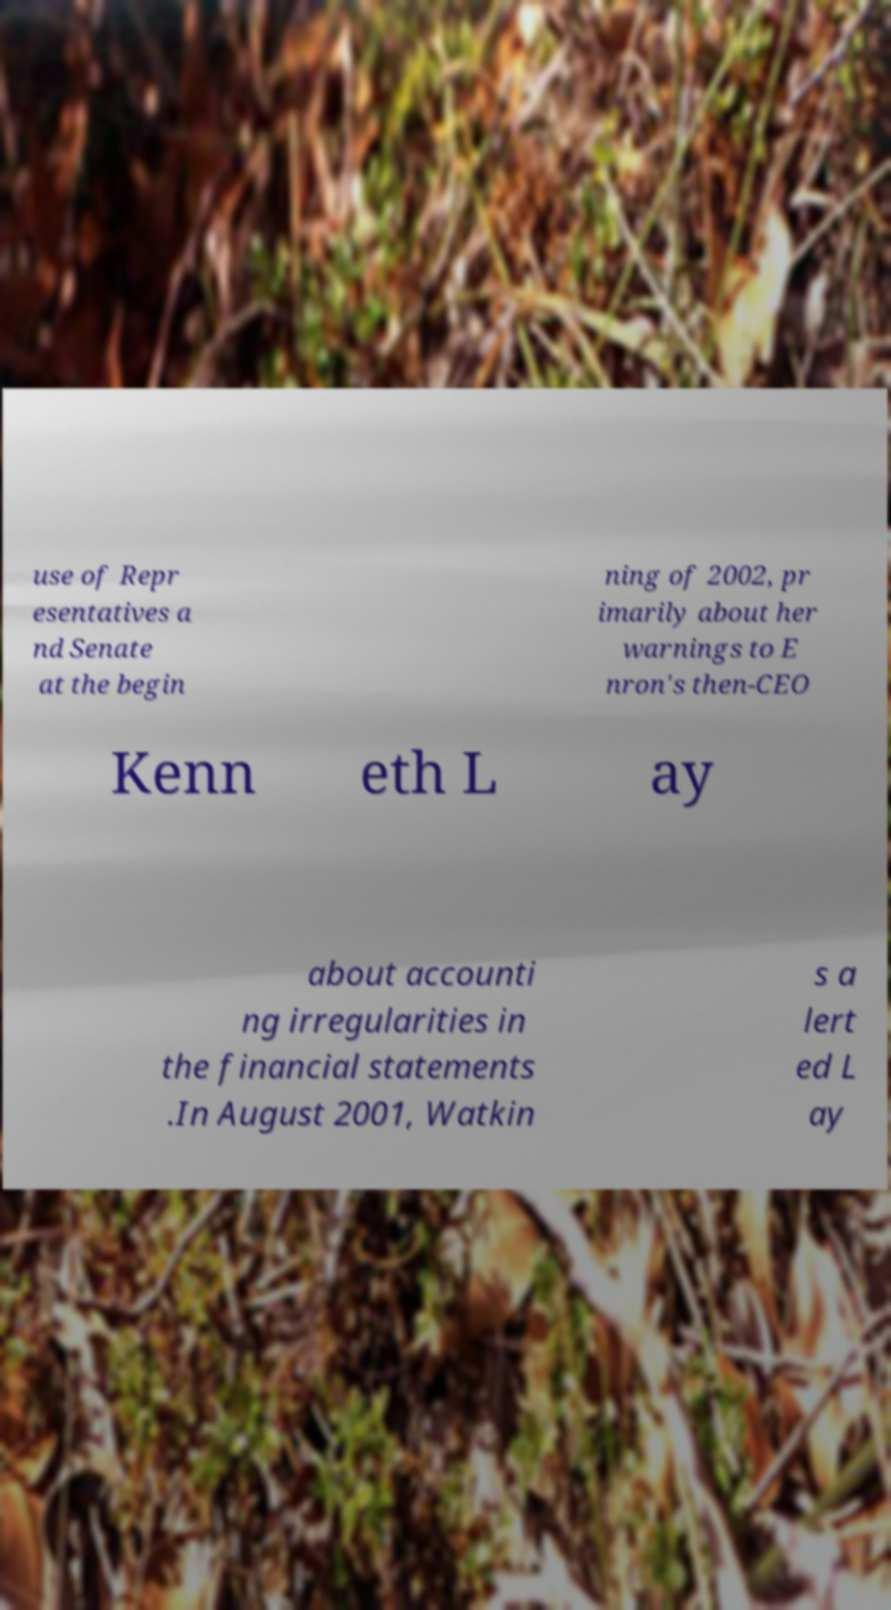Can you read and provide the text displayed in the image?This photo seems to have some interesting text. Can you extract and type it out for me? use of Repr esentatives a nd Senate at the begin ning of 2002, pr imarily about her warnings to E nron's then-CEO Kenn eth L ay about accounti ng irregularities in the financial statements .In August 2001, Watkin s a lert ed L ay 